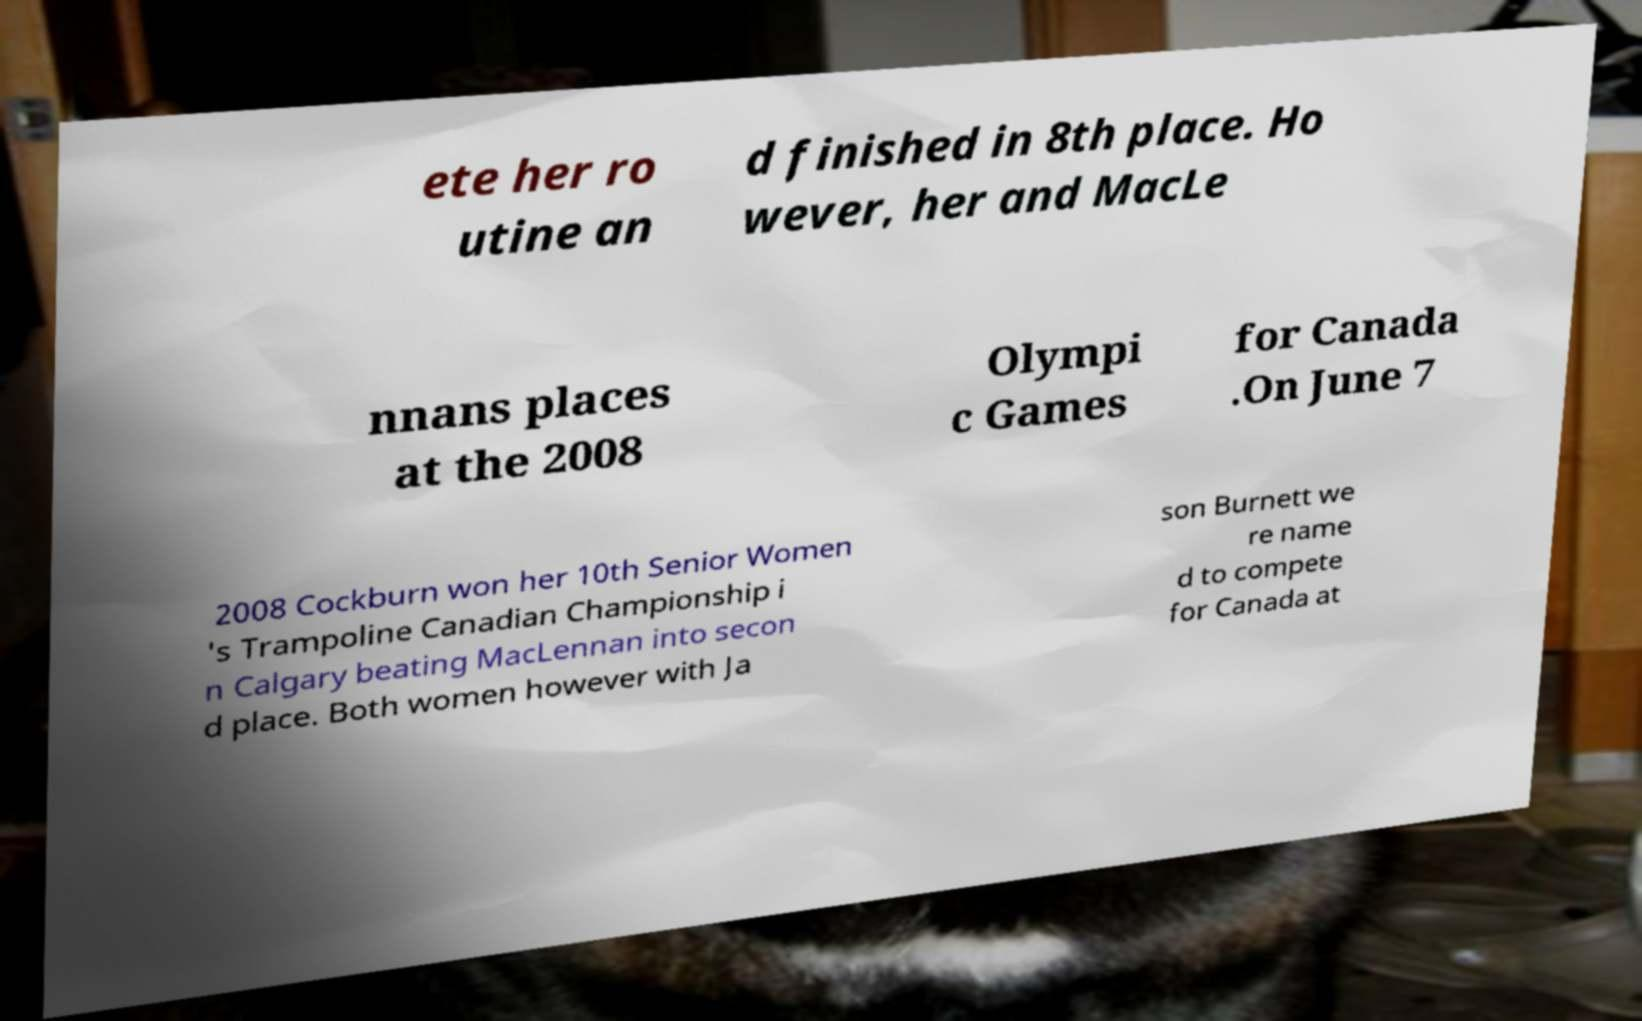Please read and relay the text visible in this image. What does it say? ete her ro utine an d finished in 8th place. Ho wever, her and MacLe nnans places at the 2008 Olympi c Games for Canada .On June 7 2008 Cockburn won her 10th Senior Women 's Trampoline Canadian Championship i n Calgary beating MacLennan into secon d place. Both women however with Ja son Burnett we re name d to compete for Canada at 